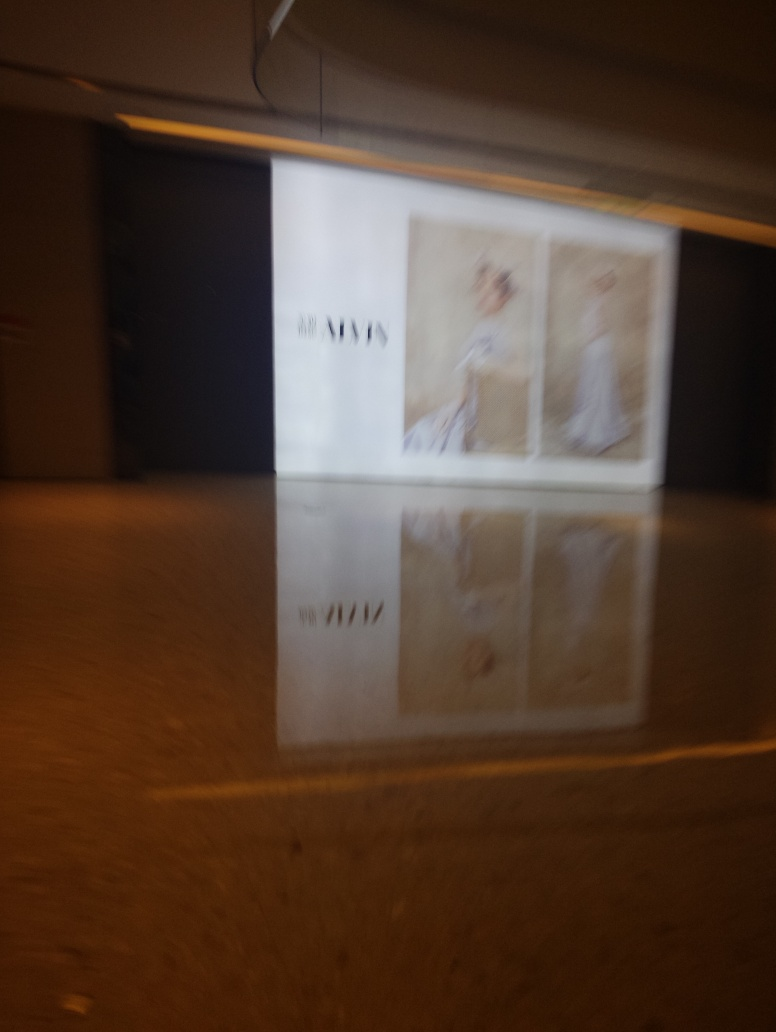Can you tell what time of day it is in this image? Determining the exact time of day from the image is challenging due to the indoor setting and lack of visible windows or natural light. However, the artificial lighting suggests it could be during operational hours of a retail space. What can you infer about the place this picture was taken? The image features an advertisement for what appears to be a fashion brand, suggesting that the place could be a shopping mall or a boutique's promotional area. The elegance of the display hints at a venue that caters to a clientele interested in high-end fashion. 